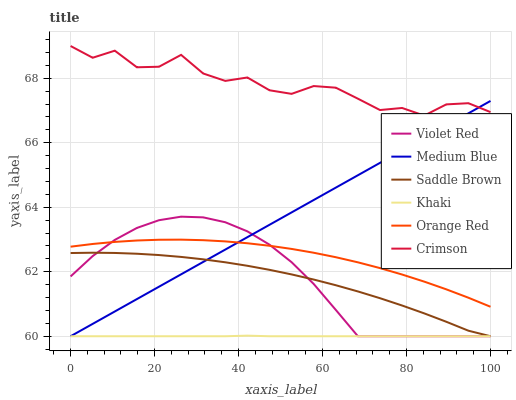Does Khaki have the minimum area under the curve?
Answer yes or no. Yes. Does Crimson have the maximum area under the curve?
Answer yes or no. Yes. Does Medium Blue have the minimum area under the curve?
Answer yes or no. No. Does Medium Blue have the maximum area under the curve?
Answer yes or no. No. Is Medium Blue the smoothest?
Answer yes or no. Yes. Is Crimson the roughest?
Answer yes or no. Yes. Is Khaki the smoothest?
Answer yes or no. No. Is Khaki the roughest?
Answer yes or no. No. Does Orange Red have the lowest value?
Answer yes or no. No. Does Crimson have the highest value?
Answer yes or no. Yes. Does Medium Blue have the highest value?
Answer yes or no. No. Is Saddle Brown less than Crimson?
Answer yes or no. Yes. Is Crimson greater than Orange Red?
Answer yes or no. Yes. Does Medium Blue intersect Saddle Brown?
Answer yes or no. Yes. Is Medium Blue less than Saddle Brown?
Answer yes or no. No. Is Medium Blue greater than Saddle Brown?
Answer yes or no. No. Does Saddle Brown intersect Crimson?
Answer yes or no. No. 